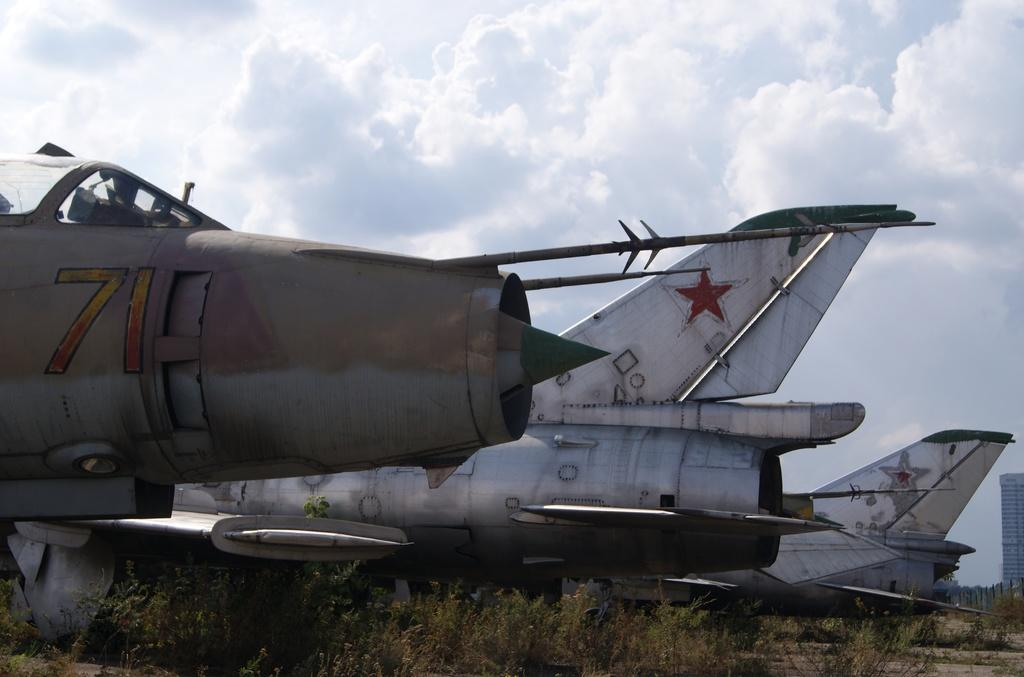Provide a one-sentence caption for the provided image. An old airplane numbered 71 rests with two otheres in a field. 